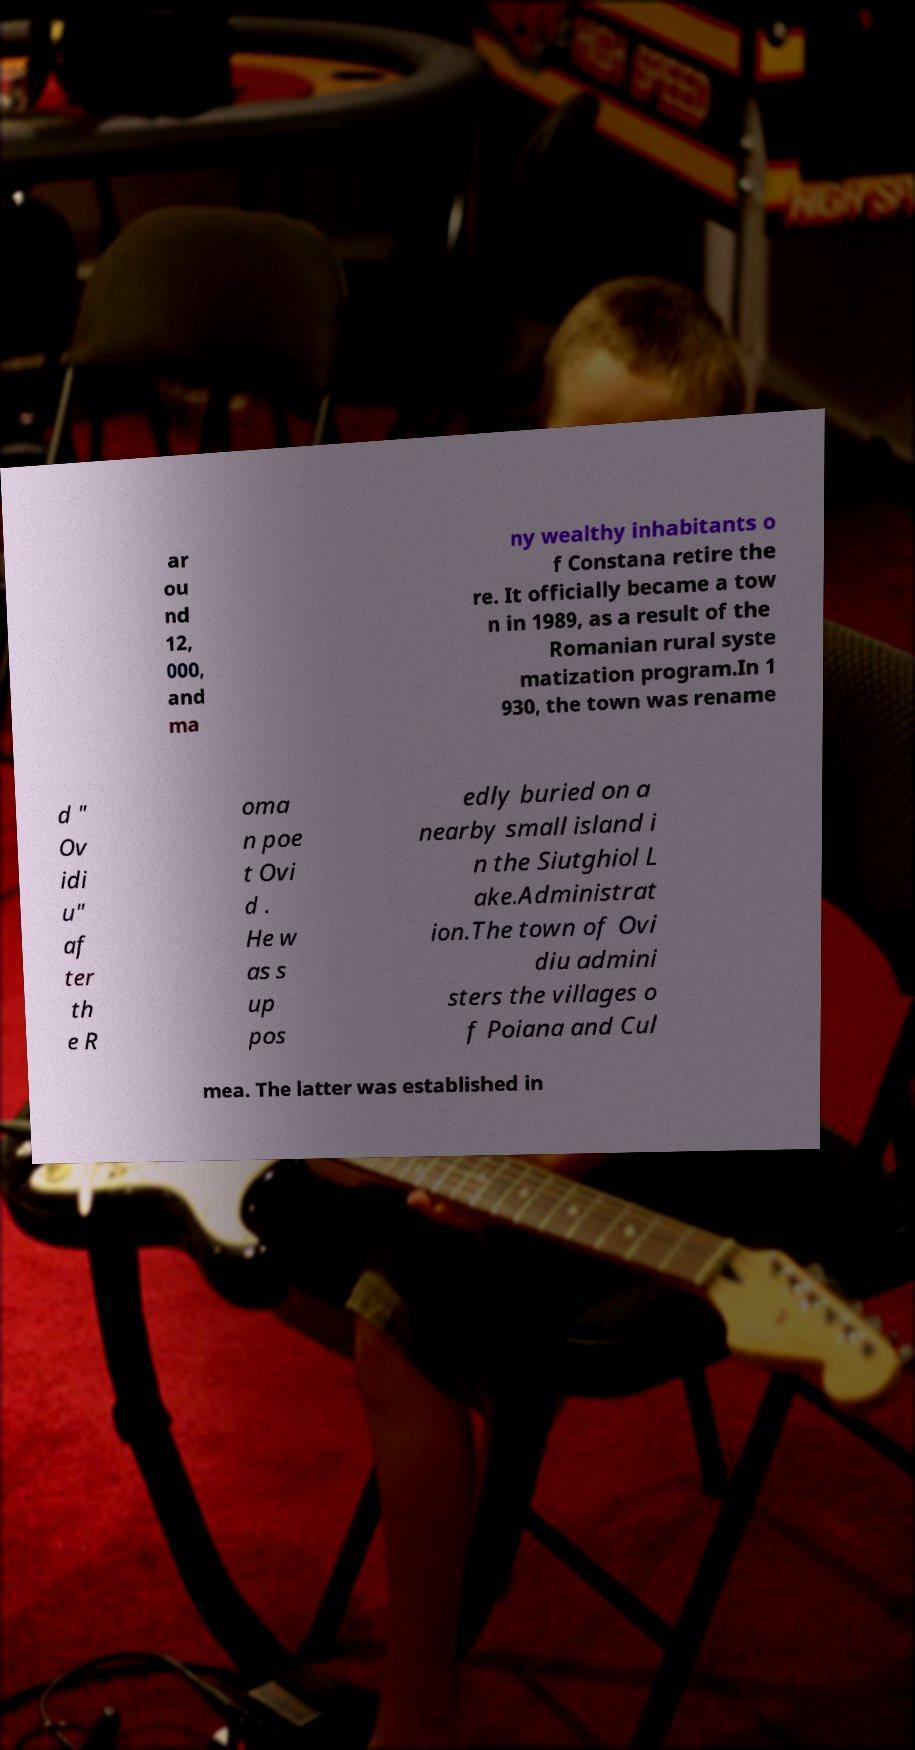Please identify and transcribe the text found in this image. ar ou nd 12, 000, and ma ny wealthy inhabitants o f Constana retire the re. It officially became a tow n in 1989, as a result of the Romanian rural syste matization program.In 1 930, the town was rename d " Ov idi u" af ter th e R oma n poe t Ovi d . He w as s up pos edly buried on a nearby small island i n the Siutghiol L ake.Administrat ion.The town of Ovi diu admini sters the villages o f Poiana and Cul mea. The latter was established in 